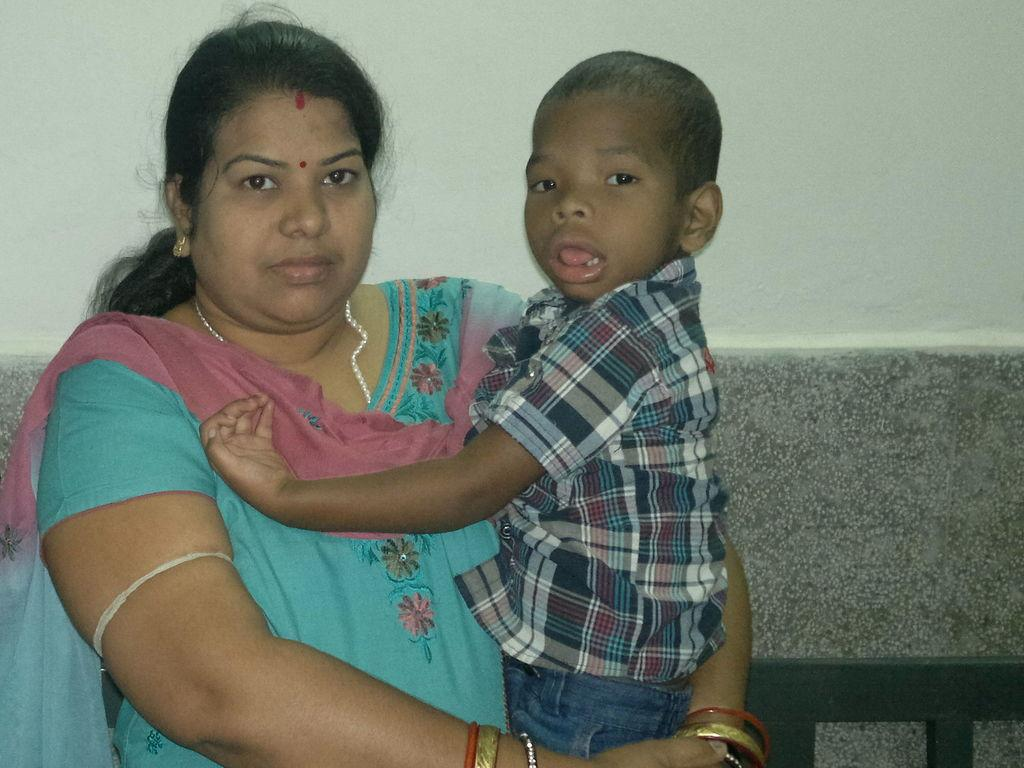Who is the main subject in the image? There is a woman in the image. What is the woman wearing? The woman is wearing a blue and pink dress. What is the woman doing in the image? The woman is carrying a boy. What can be seen in the background of the image? There is a wall in the background of the image. What type of spy equipment can be seen in the woman's hand in the image? There is no spy equipment visible in the woman's hand in the image. What is the woman using to join the boy to the wall in the image? The woman is not using any equipment to join the boy to the wall in the image; she is simply carrying him. 